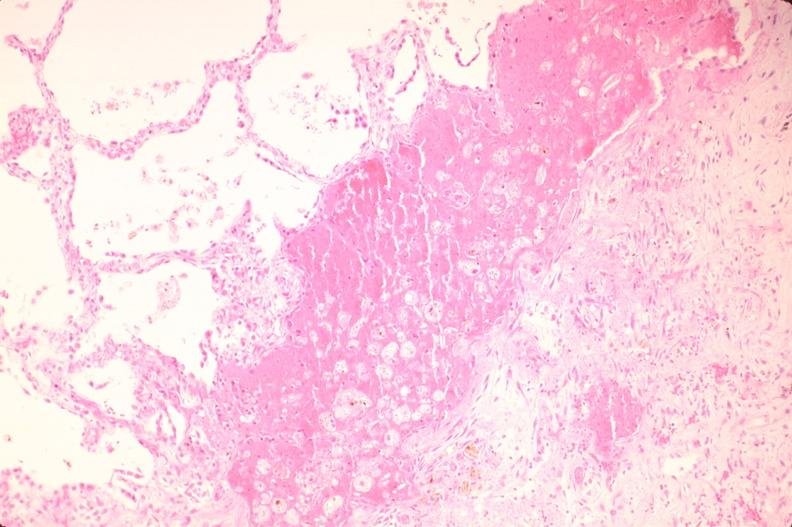does neurofibrillary change show lung, infarct, acute and organized?
Answer the question using a single word or phrase. No 